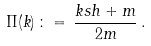<formula> <loc_0><loc_0><loc_500><loc_500>\Pi ( k ) \, \colon = \, \frac { k \sl s h + m } { 2 m } \, .</formula> 